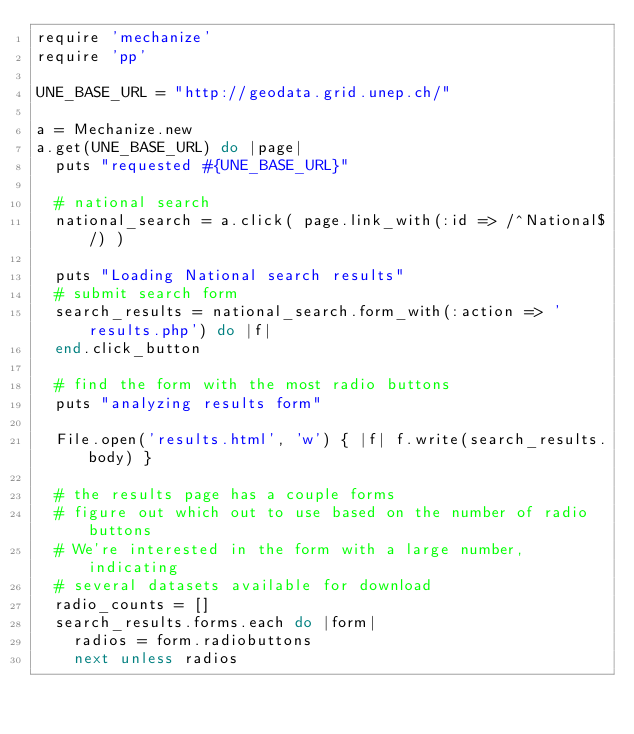Convert code to text. <code><loc_0><loc_0><loc_500><loc_500><_Ruby_>require 'mechanize'
require 'pp'

UNE_BASE_URL = "http://geodata.grid.unep.ch/"

a = Mechanize.new
a.get(UNE_BASE_URL) do |page|
  puts "requested #{UNE_BASE_URL}"
  
  # national search
  national_search = a.click( page.link_with(:id => /^National$/) )
  
  puts "Loading National search results"
  # submit search form
  search_results = national_search.form_with(:action => 'results.php') do |f|
  end.click_button
  
  # find the form with the most radio buttons
  puts "analyzing results form"
  
  File.open('results.html', 'w') { |f| f.write(search_results.body) }
  
  # the results page has a couple forms
  # figure out which out to use based on the number of radio buttons
  # We're interested in the form with a large number, indicating
  # several datasets available for download
  radio_counts = []
  search_results.forms.each do |form|
    radios = form.radiobuttons
    next unless radios
    </code> 